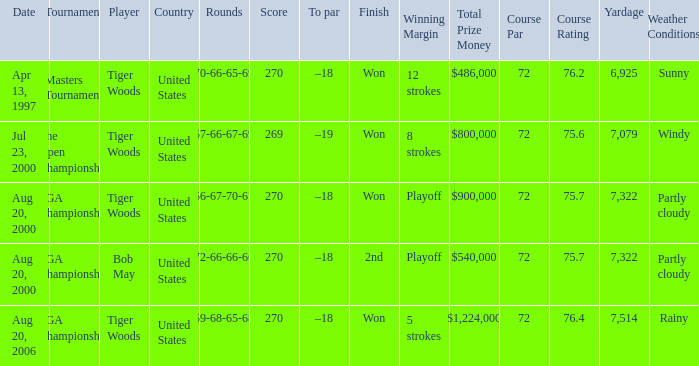What is the worst (highest) score? 270.0. 